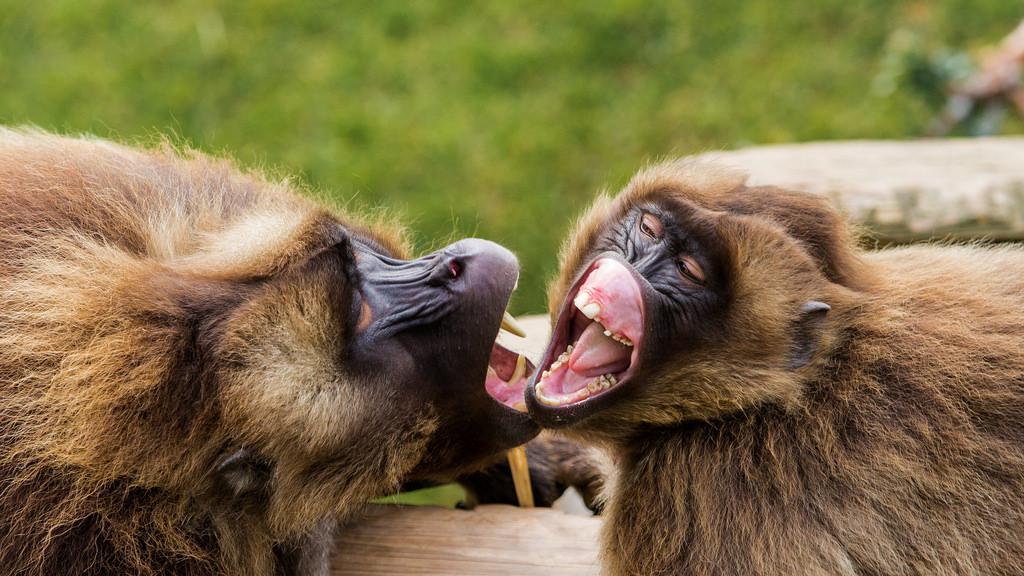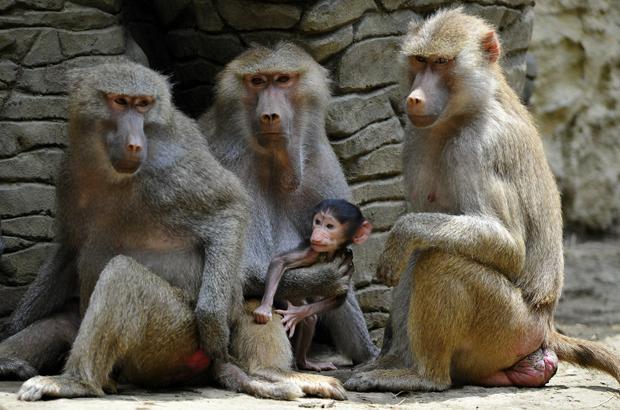The first image is the image on the left, the second image is the image on the right. Evaluate the accuracy of this statement regarding the images: "There are more primates in the image on the right.". Is it true? Answer yes or no. Yes. The first image is the image on the left, the second image is the image on the right. For the images displayed, is the sentence "At least one baboon is on the back of an animal bigger than itself, and no image contains more than two baboons." factually correct? Answer yes or no. No. 